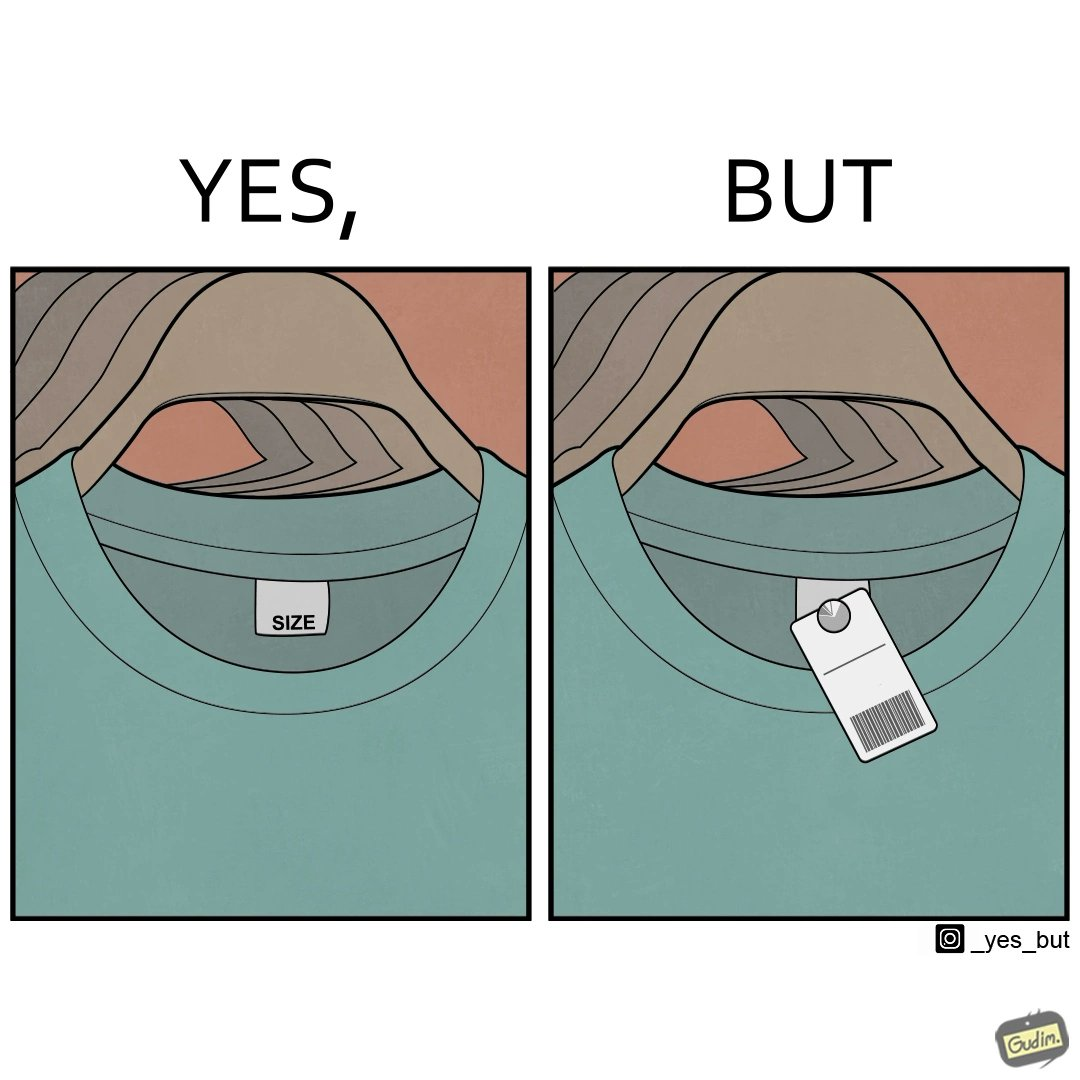Why is this image considered satirical? The image is ironic, because it shows over modernization, earlier the size was printed on the label attached to the clothes but now for knowing even the basic details about the cloth like size there is some barcode or QR code attached which need to be scanned by some mobile phone or electronic device 